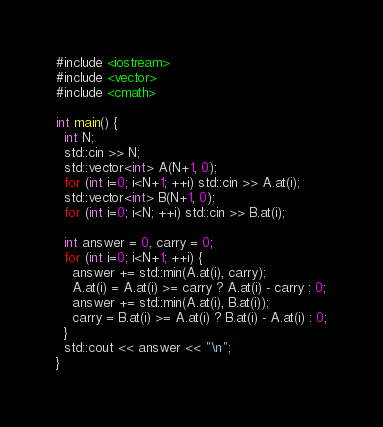Convert code to text. <code><loc_0><loc_0><loc_500><loc_500><_C++_>#include <iostream>
#include <vector>
#include <cmath>

int main() {
  int N;
  std::cin >> N;
  std::vector<int> A(N+1, 0);
  for (int i=0; i<N+1; ++i) std::cin >> A.at(i);
  std::vector<int> B(N+1, 0);
  for (int i=0; i<N; ++i) std::cin >> B.at(i);
  
  int answer = 0, carry = 0;
  for (int i=0; i<N+1; ++i) {
    answer += std::min(A.at(i), carry);
    A.at(i) = A.at(i) >= carry ? A.at(i) - carry : 0;
    answer += std::min(A.at(i), B.at(i));
    carry = B.at(i) >= A.at(i) ? B.at(i) - A.at(i) : 0;
  }
  std::cout << answer << "\n";
}</code> 